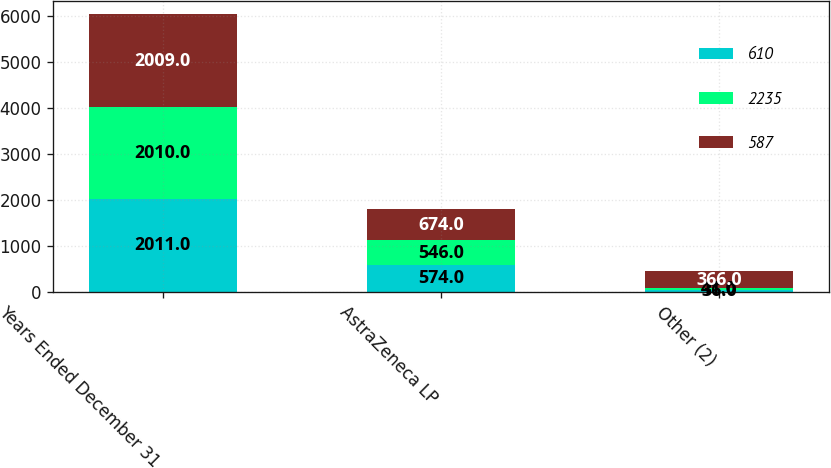Convert chart. <chart><loc_0><loc_0><loc_500><loc_500><stacked_bar_chart><ecel><fcel>Years Ended December 31<fcel>AstraZeneca LP<fcel>Other (2)<nl><fcel>610<fcel>2011<fcel>574<fcel>36<nl><fcel>2235<fcel>2010<fcel>546<fcel>41<nl><fcel>587<fcel>2009<fcel>674<fcel>366<nl></chart> 